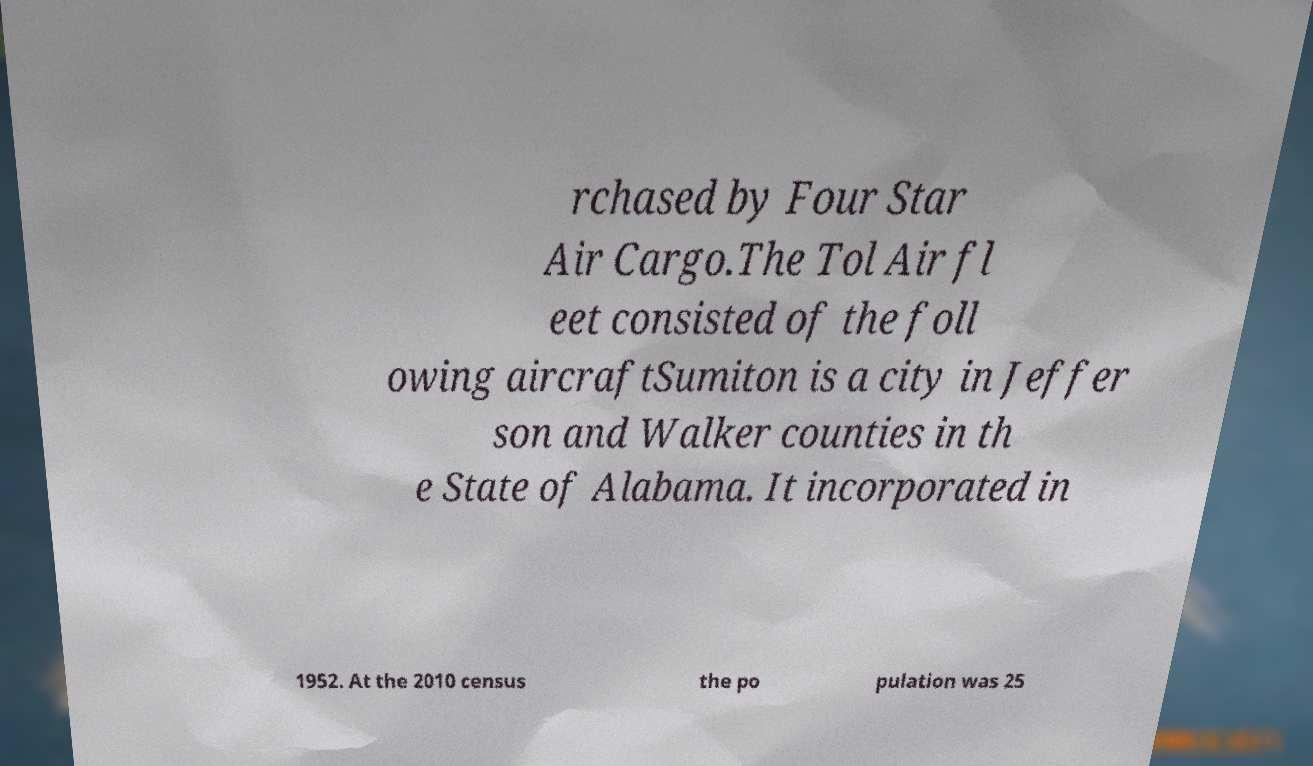Can you read and provide the text displayed in the image?This photo seems to have some interesting text. Can you extract and type it out for me? rchased by Four Star Air Cargo.The Tol Air fl eet consisted of the foll owing aircraftSumiton is a city in Jeffer son and Walker counties in th e State of Alabama. It incorporated in 1952. At the 2010 census the po pulation was 25 